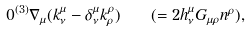<formula> <loc_0><loc_0><loc_500><loc_500>0 ^ { ( 3 ) } \nabla _ { \mu } ( k ^ { \mu } _ { \nu } - \delta ^ { \mu } _ { \nu } k ^ { \rho } _ { \rho } ) \quad ( = 2 h _ { \nu } ^ { \mu } G _ { \mu \rho } n ^ { \rho } ) ,</formula> 